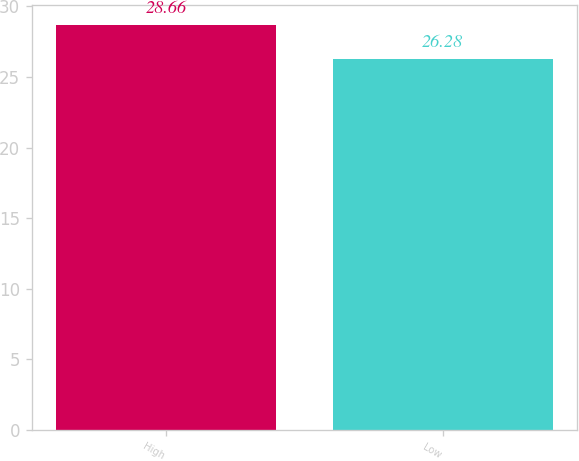Convert chart to OTSL. <chart><loc_0><loc_0><loc_500><loc_500><bar_chart><fcel>High<fcel>Low<nl><fcel>28.66<fcel>26.28<nl></chart> 